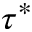Convert formula to latex. <formula><loc_0><loc_0><loc_500><loc_500>\tau ^ { * }</formula> 